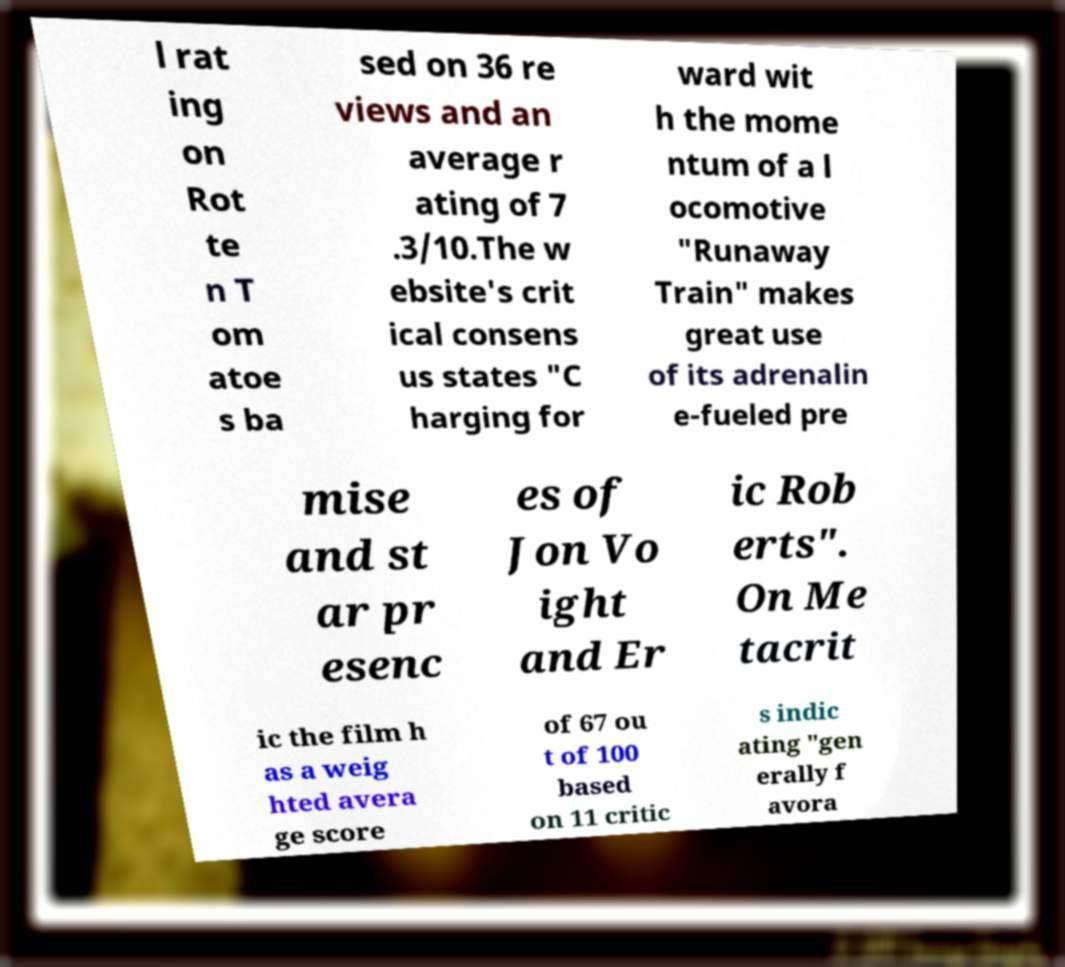Can you accurately transcribe the text from the provided image for me? l rat ing on Rot te n T om atoe s ba sed on 36 re views and an average r ating of 7 .3/10.The w ebsite's crit ical consens us states "C harging for ward wit h the mome ntum of a l ocomotive "Runaway Train" makes great use of its adrenalin e-fueled pre mise and st ar pr esenc es of Jon Vo ight and Er ic Rob erts". On Me tacrit ic the film h as a weig hted avera ge score of 67 ou t of 100 based on 11 critic s indic ating "gen erally f avora 